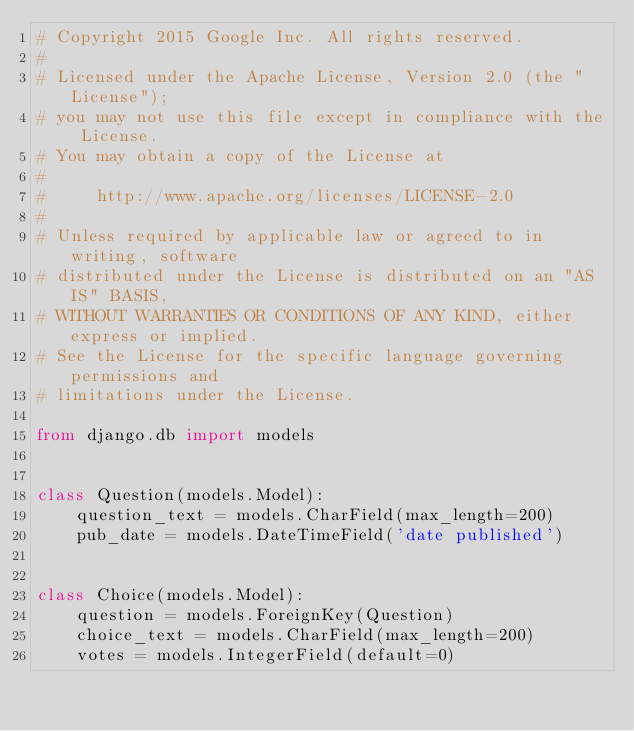<code> <loc_0><loc_0><loc_500><loc_500><_Python_># Copyright 2015 Google Inc. All rights reserved.
#
# Licensed under the Apache License, Version 2.0 (the "License");
# you may not use this file except in compliance with the License.
# You may obtain a copy of the License at
#
#     http://www.apache.org/licenses/LICENSE-2.0
#
# Unless required by applicable law or agreed to in writing, software
# distributed under the License is distributed on an "AS IS" BASIS,
# WITHOUT WARRANTIES OR CONDITIONS OF ANY KIND, either express or implied.
# See the License for the specific language governing permissions and
# limitations under the License.

from django.db import models


class Question(models.Model):
    question_text = models.CharField(max_length=200)
    pub_date = models.DateTimeField('date published')


class Choice(models.Model):
    question = models.ForeignKey(Question)
    choice_text = models.CharField(max_length=200)
    votes = models.IntegerField(default=0)
</code> 